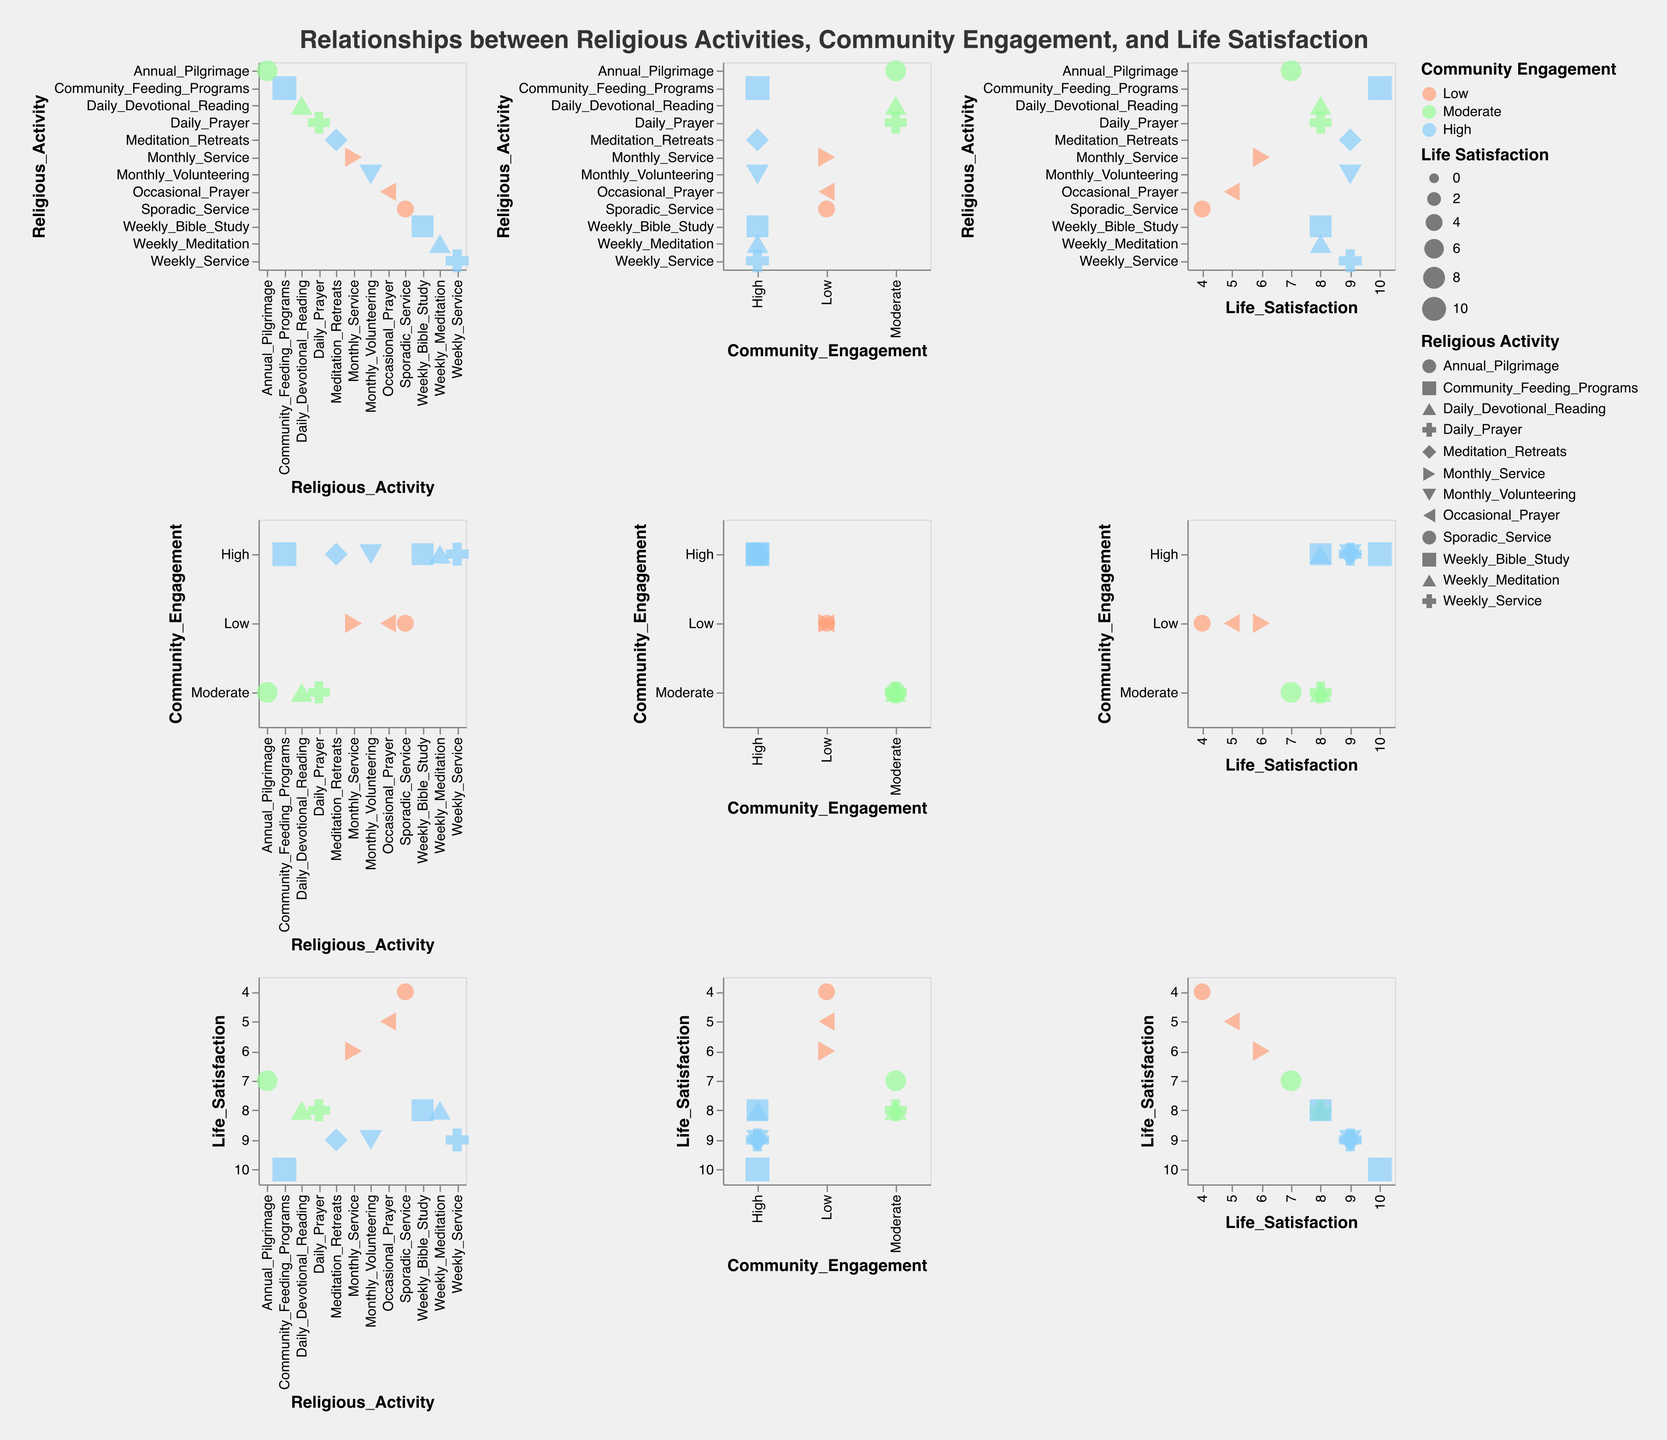What are the axes labeled in the plot? The plot's axes are labeled based on the repeated fields, which are "Religious Activity," "Community Engagement," and "Life Satisfaction." This implies that each small plot within the SPLOM shows relationships between these variables.
Answer: "Religious Activity," "Community Engagement," and "Life Satisfaction" How many unique Religious Activities are displayed? Each point in the plot represents a unique religious activity, indicated by different shapes. By counting the distinct shapes, we can determine there are 12 unique religious activities.
Answer: 12 Which community engagement level corresponds to the highest life satisfaction? By examining the color of the point with the largest size, we see the point under "Community_Feeding_Programs" has "High" community engagement and the highest life satisfaction of 10.
Answer: High How does "Daily_Prayer" compare to "Weekly_Service" in terms of Community Engagement and Life Satisfaction? "Daily_Prayer" is associated with "Moderate" Community Engagement and a Life Satisfaction of 8, whereas "Weekly_Service" has "High" Community Engagement and a Life Satisfaction of 9. Comparing these, "Weekly_Service" has higher community engagement and life satisfaction.
Answer: "Weekly_Service" has higher community engagement and life satisfaction Are there more data points with "High" or "Low" community engagement? Count the number of points colored with "High" (light blue) and "Low" (light coral). There are 7 points with "High" community engagement and 3 points with "Low" community engagement.
Answer: High What's the overall trend between Community Engagement and Life Satisfaction? By observing the distribution of data points based on color and size, we notice that higher life satisfaction is generally associated with higher community engagement levels.
Answer: Higher community engagement often coincides with higher life satisfaction What is the typical life satisfaction for activities with "Moderate" community engagement? Considering points colored light green (Moderate), we look at their sizes representing life satisfaction. The life satisfaction values are 8, 7, and 8. The average life satisfaction for moderate engagement is (8+7+8)/3 = 7.67.
Answer: 7.67 Which religious activity has the lowest life satisfaction, and what is its community engagement level? Identifying the smallest-sized point corresponds to "Sporadic_Service," which has a life satisfaction of 4 and a community engagement level of "Low."
Answer: "Sporadic_Service," Low How many religious activities are associated with a life satisfaction of 9? Points with the same size representing 9 can be counted. These points are "Weekly_Service," "Meditation_Retreats," "Community_Feeding_Programs," and "Monthly_Volunteering."
Answer: 4 Do activities with the same level of community engagement show similar life satisfaction? By examining points with identical colors for community engagement (e.g., High: light blue), we see that different activities within the same engagement level can have varying life satisfaction sizes.
Answer: No 